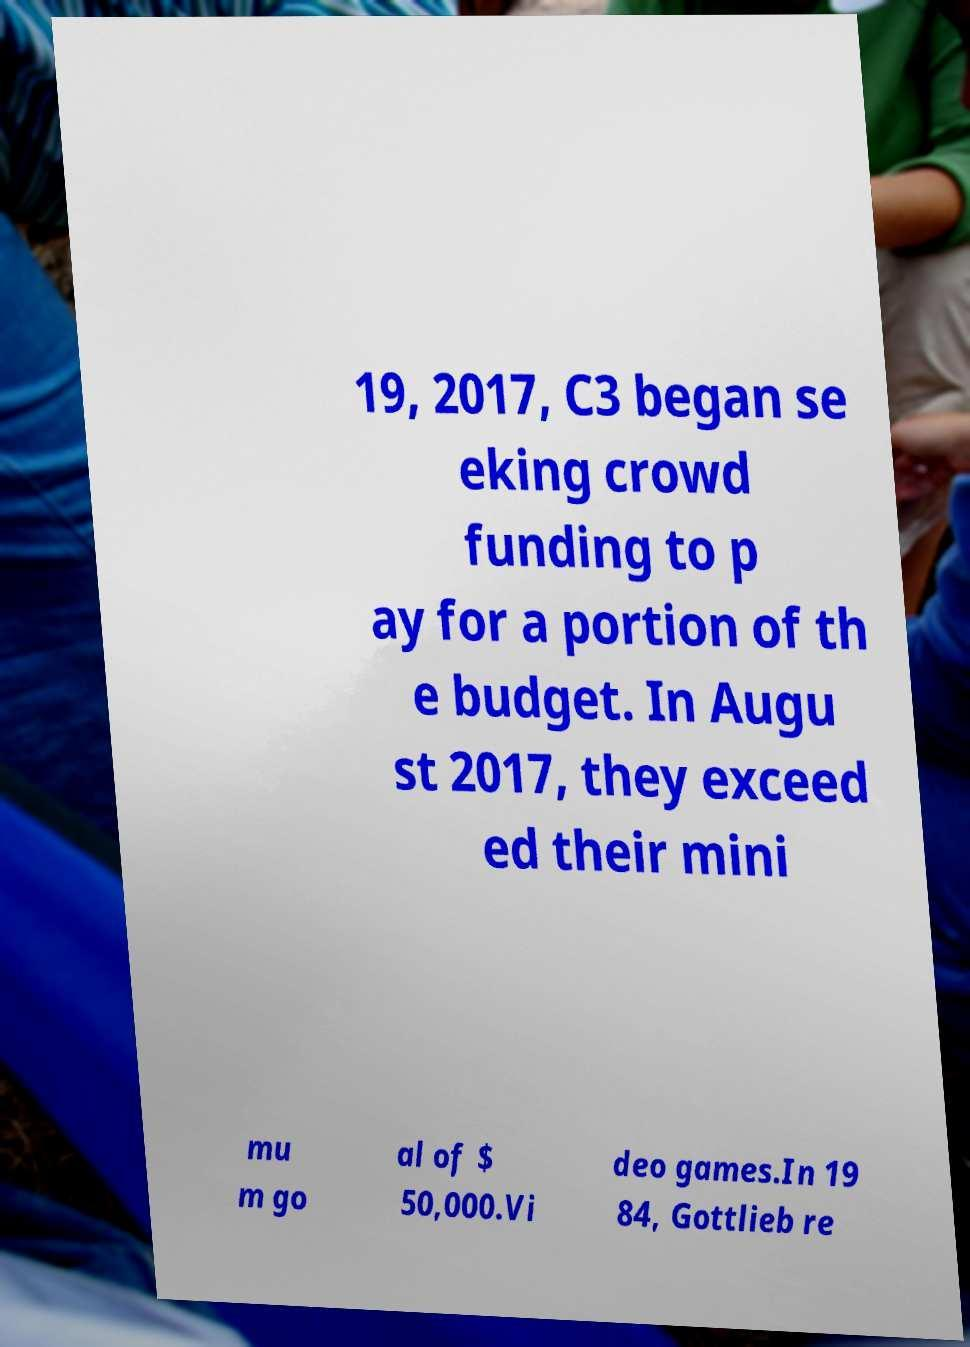For documentation purposes, I need the text within this image transcribed. Could you provide that? 19, 2017, C3 began se eking crowd funding to p ay for a portion of th e budget. In Augu st 2017, they exceed ed their mini mu m go al of $ 50,000.Vi deo games.In 19 84, Gottlieb re 